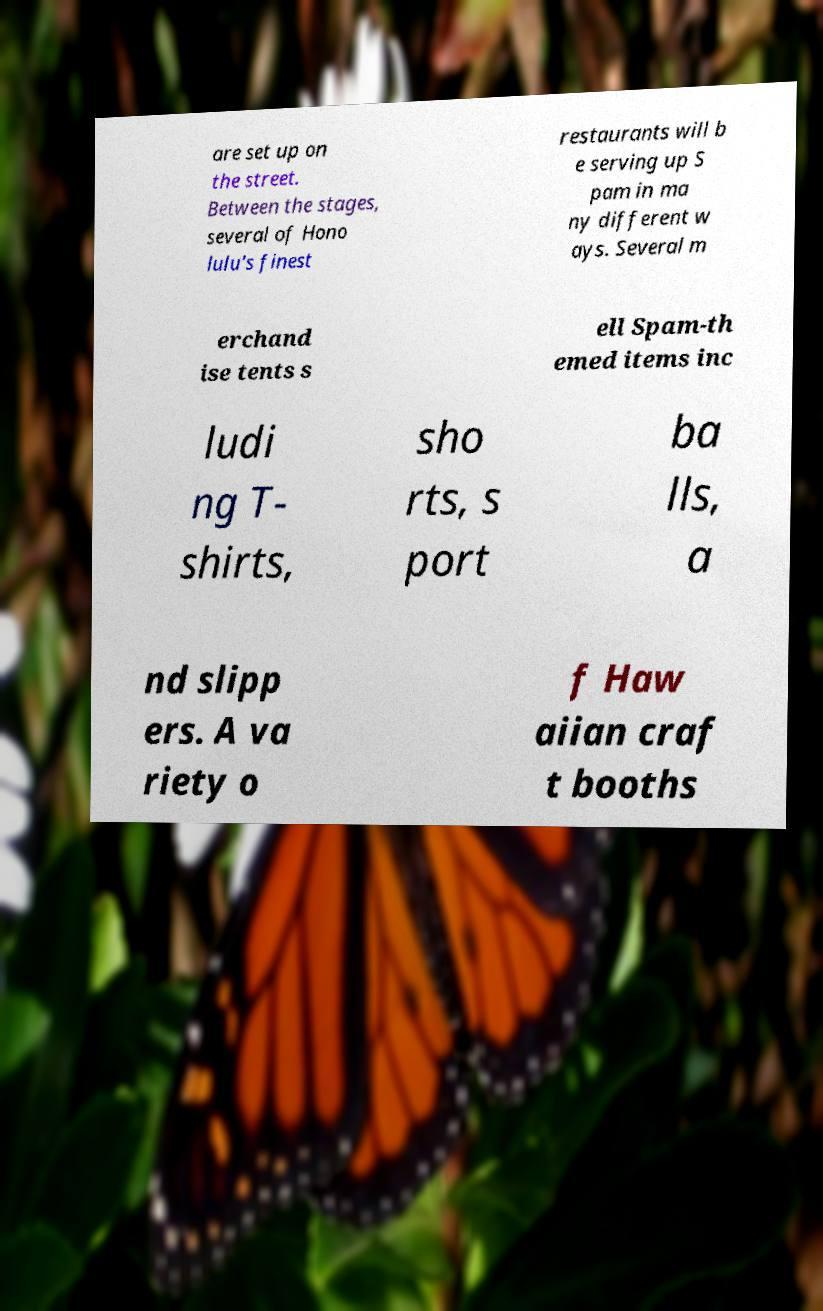There's text embedded in this image that I need extracted. Can you transcribe it verbatim? are set up on the street. Between the stages, several of Hono lulu's finest restaurants will b e serving up S pam in ma ny different w ays. Several m erchand ise tents s ell Spam-th emed items inc ludi ng T- shirts, sho rts, s port ba lls, a nd slipp ers. A va riety o f Haw aiian craf t booths 